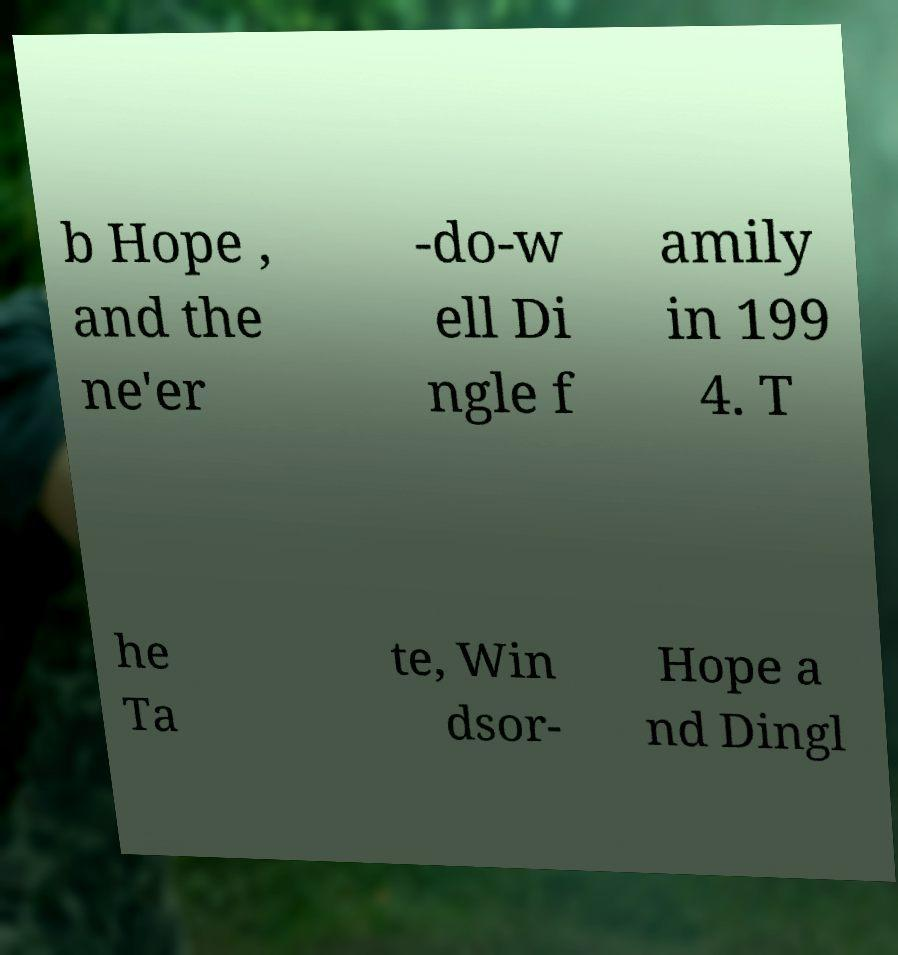Could you assist in decoding the text presented in this image and type it out clearly? b Hope , and the ne'er -do-w ell Di ngle f amily in 199 4. T he Ta te, Win dsor- Hope a nd Dingl 